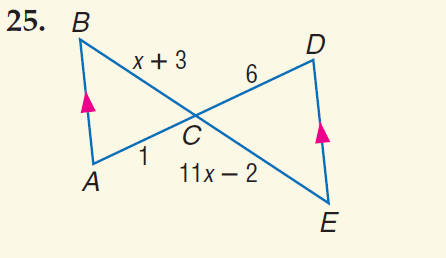Question: Find x.
Choices:
A. 3
B. 4
C. 6
D. 7
Answer with the letter. Answer: B 